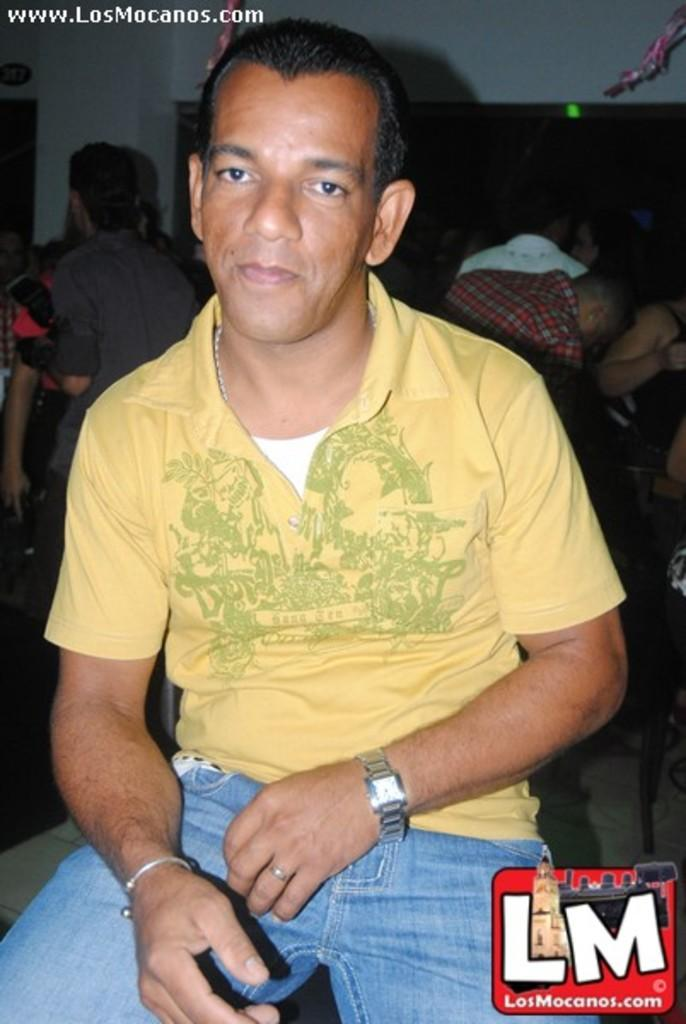Who is present in the image? There is a person in the image. What is the person wearing on their upper body? The person is wearing a yellow t-shirt. What accessory can be seen on the person's wrist? The person is wearing a watch. Can you describe the surrounding environment in the image? There are other people visible in the background of the image. What type of blood is visible on the person's glove in the image? There is no glove or blood present in the image. What appliance is the person using in the image? There is no appliance visible in the image; it only features a person wearing a yellow t-shirt and a watch, with other people in the background. 